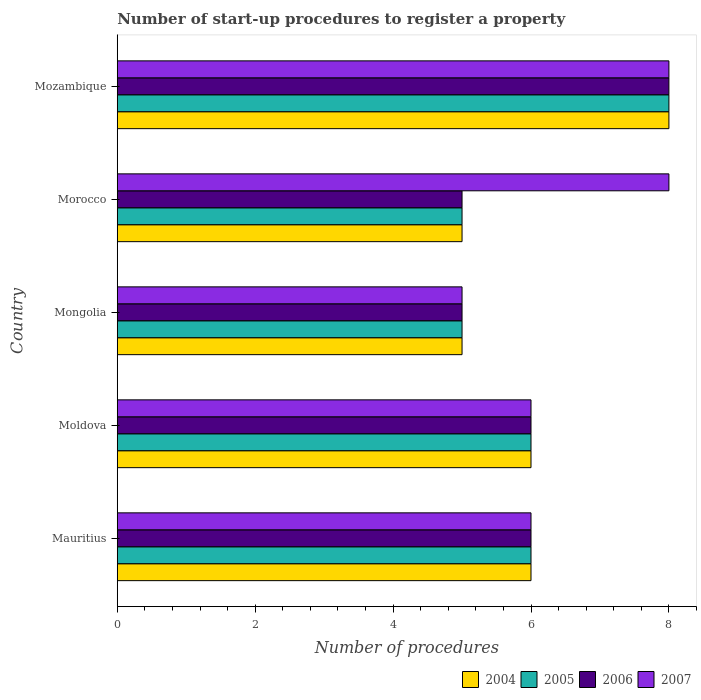How many groups of bars are there?
Make the answer very short. 5. Are the number of bars per tick equal to the number of legend labels?
Your response must be concise. Yes. How many bars are there on the 1st tick from the top?
Make the answer very short. 4. How many bars are there on the 2nd tick from the bottom?
Give a very brief answer. 4. What is the label of the 2nd group of bars from the top?
Provide a short and direct response. Morocco. Across all countries, what is the minimum number of procedures required to register a property in 2004?
Provide a short and direct response. 5. In which country was the number of procedures required to register a property in 2004 maximum?
Offer a very short reply. Mozambique. In which country was the number of procedures required to register a property in 2005 minimum?
Offer a terse response. Mongolia. What is the difference between the number of procedures required to register a property in 2005 in Moldova and that in Mongolia?
Your answer should be compact. 1. What is the difference between the number of procedures required to register a property in 2007 in Moldova and the number of procedures required to register a property in 2005 in Mauritius?
Offer a very short reply. 0. Is the number of procedures required to register a property in 2004 in Moldova less than that in Mongolia?
Offer a very short reply. No. Is the difference between the number of procedures required to register a property in 2007 in Moldova and Mozambique greater than the difference between the number of procedures required to register a property in 2004 in Moldova and Mozambique?
Your response must be concise. No. What is the difference between the highest and the second highest number of procedures required to register a property in 2007?
Offer a terse response. 0. Is the sum of the number of procedures required to register a property in 2004 in Mongolia and Mozambique greater than the maximum number of procedures required to register a property in 2007 across all countries?
Keep it short and to the point. Yes. What does the 1st bar from the top in Mauritius represents?
Your response must be concise. 2007. Is it the case that in every country, the sum of the number of procedures required to register a property in 2007 and number of procedures required to register a property in 2005 is greater than the number of procedures required to register a property in 2004?
Offer a terse response. Yes. How many bars are there?
Keep it short and to the point. 20. Are all the bars in the graph horizontal?
Give a very brief answer. Yes. What is the difference between two consecutive major ticks on the X-axis?
Provide a short and direct response. 2. How many legend labels are there?
Your response must be concise. 4. How are the legend labels stacked?
Your answer should be compact. Horizontal. What is the title of the graph?
Your answer should be very brief. Number of start-up procedures to register a property. Does "1968" appear as one of the legend labels in the graph?
Your response must be concise. No. What is the label or title of the X-axis?
Make the answer very short. Number of procedures. What is the label or title of the Y-axis?
Offer a very short reply. Country. What is the Number of procedures in 2004 in Mauritius?
Ensure brevity in your answer.  6. What is the Number of procedures of 2005 in Moldova?
Give a very brief answer. 6. What is the Number of procedures in 2006 in Moldova?
Provide a short and direct response. 6. What is the Number of procedures in 2007 in Moldova?
Your answer should be compact. 6. What is the Number of procedures in 2004 in Mongolia?
Ensure brevity in your answer.  5. What is the Number of procedures in 2005 in Mongolia?
Make the answer very short. 5. What is the Number of procedures of 2004 in Morocco?
Your response must be concise. 5. What is the Number of procedures of 2006 in Morocco?
Provide a short and direct response. 5. What is the Number of procedures in 2005 in Mozambique?
Give a very brief answer. 8. What is the Number of procedures in 2006 in Mozambique?
Your response must be concise. 8. What is the Number of procedures in 2007 in Mozambique?
Make the answer very short. 8. Across all countries, what is the maximum Number of procedures of 2004?
Ensure brevity in your answer.  8. Across all countries, what is the maximum Number of procedures of 2005?
Offer a terse response. 8. Across all countries, what is the minimum Number of procedures in 2005?
Your answer should be very brief. 5. What is the total Number of procedures in 2004 in the graph?
Your response must be concise. 30. What is the total Number of procedures of 2005 in the graph?
Provide a succinct answer. 30. What is the difference between the Number of procedures of 2004 in Mauritius and that in Moldova?
Make the answer very short. 0. What is the difference between the Number of procedures of 2005 in Mauritius and that in Moldova?
Keep it short and to the point. 0. What is the difference between the Number of procedures in 2006 in Mauritius and that in Moldova?
Keep it short and to the point. 0. What is the difference between the Number of procedures in 2005 in Mauritius and that in Mongolia?
Your answer should be compact. 1. What is the difference between the Number of procedures in 2007 in Mauritius and that in Mongolia?
Provide a succinct answer. 1. What is the difference between the Number of procedures in 2004 in Mauritius and that in Morocco?
Your answer should be compact. 1. What is the difference between the Number of procedures in 2006 in Mauritius and that in Morocco?
Give a very brief answer. 1. What is the difference between the Number of procedures in 2007 in Mauritius and that in Morocco?
Make the answer very short. -2. What is the difference between the Number of procedures in 2004 in Mauritius and that in Mozambique?
Offer a very short reply. -2. What is the difference between the Number of procedures in 2005 in Mauritius and that in Mozambique?
Provide a succinct answer. -2. What is the difference between the Number of procedures in 2006 in Mauritius and that in Mozambique?
Ensure brevity in your answer.  -2. What is the difference between the Number of procedures of 2007 in Mauritius and that in Mozambique?
Make the answer very short. -2. What is the difference between the Number of procedures in 2004 in Moldova and that in Mongolia?
Provide a short and direct response. 1. What is the difference between the Number of procedures of 2005 in Moldova and that in Mongolia?
Give a very brief answer. 1. What is the difference between the Number of procedures of 2007 in Moldova and that in Mongolia?
Offer a terse response. 1. What is the difference between the Number of procedures in 2004 in Moldova and that in Morocco?
Make the answer very short. 1. What is the difference between the Number of procedures of 2005 in Moldova and that in Morocco?
Offer a very short reply. 1. What is the difference between the Number of procedures in 2005 in Mongolia and that in Mozambique?
Give a very brief answer. -3. What is the difference between the Number of procedures in 2007 in Mongolia and that in Mozambique?
Offer a terse response. -3. What is the difference between the Number of procedures in 2004 in Morocco and that in Mozambique?
Offer a terse response. -3. What is the difference between the Number of procedures in 2005 in Morocco and that in Mozambique?
Your answer should be very brief. -3. What is the difference between the Number of procedures in 2007 in Morocco and that in Mozambique?
Your answer should be very brief. 0. What is the difference between the Number of procedures in 2004 in Mauritius and the Number of procedures in 2005 in Moldova?
Make the answer very short. 0. What is the difference between the Number of procedures in 2004 in Mauritius and the Number of procedures in 2007 in Moldova?
Provide a short and direct response. 0. What is the difference between the Number of procedures in 2005 in Mauritius and the Number of procedures in 2006 in Moldova?
Provide a short and direct response. 0. What is the difference between the Number of procedures of 2004 in Mauritius and the Number of procedures of 2006 in Mongolia?
Offer a very short reply. 1. What is the difference between the Number of procedures of 2005 in Mauritius and the Number of procedures of 2006 in Mongolia?
Ensure brevity in your answer.  1. What is the difference between the Number of procedures in 2005 in Mauritius and the Number of procedures in 2007 in Mongolia?
Your response must be concise. 1. What is the difference between the Number of procedures in 2004 in Mauritius and the Number of procedures in 2005 in Morocco?
Offer a very short reply. 1. What is the difference between the Number of procedures in 2004 in Mauritius and the Number of procedures in 2006 in Morocco?
Provide a short and direct response. 1. What is the difference between the Number of procedures of 2004 in Mauritius and the Number of procedures of 2007 in Morocco?
Your response must be concise. -2. What is the difference between the Number of procedures in 2005 in Mauritius and the Number of procedures in 2006 in Morocco?
Provide a succinct answer. 1. What is the difference between the Number of procedures in 2005 in Mauritius and the Number of procedures in 2007 in Morocco?
Your answer should be very brief. -2. What is the difference between the Number of procedures in 2004 in Mauritius and the Number of procedures in 2005 in Mozambique?
Give a very brief answer. -2. What is the difference between the Number of procedures in 2004 in Mauritius and the Number of procedures in 2006 in Mozambique?
Provide a short and direct response. -2. What is the difference between the Number of procedures of 2004 in Mauritius and the Number of procedures of 2007 in Mozambique?
Provide a succinct answer. -2. What is the difference between the Number of procedures in 2006 in Mauritius and the Number of procedures in 2007 in Mozambique?
Keep it short and to the point. -2. What is the difference between the Number of procedures in 2004 in Moldova and the Number of procedures in 2006 in Mongolia?
Keep it short and to the point. 1. What is the difference between the Number of procedures of 2004 in Moldova and the Number of procedures of 2007 in Mongolia?
Provide a short and direct response. 1. What is the difference between the Number of procedures in 2006 in Moldova and the Number of procedures in 2007 in Mongolia?
Make the answer very short. 1. What is the difference between the Number of procedures of 2004 in Moldova and the Number of procedures of 2005 in Morocco?
Ensure brevity in your answer.  1. What is the difference between the Number of procedures in 2004 in Moldova and the Number of procedures in 2006 in Morocco?
Ensure brevity in your answer.  1. What is the difference between the Number of procedures in 2004 in Moldova and the Number of procedures in 2007 in Morocco?
Give a very brief answer. -2. What is the difference between the Number of procedures in 2006 in Moldova and the Number of procedures in 2007 in Morocco?
Your answer should be compact. -2. What is the difference between the Number of procedures of 2004 in Moldova and the Number of procedures of 2005 in Mozambique?
Your answer should be very brief. -2. What is the difference between the Number of procedures of 2004 in Moldova and the Number of procedures of 2006 in Mozambique?
Offer a terse response. -2. What is the difference between the Number of procedures in 2005 in Moldova and the Number of procedures in 2007 in Mozambique?
Your answer should be compact. -2. What is the difference between the Number of procedures of 2004 in Mongolia and the Number of procedures of 2006 in Morocco?
Provide a succinct answer. 0. What is the difference between the Number of procedures of 2004 in Mongolia and the Number of procedures of 2007 in Morocco?
Provide a succinct answer. -3. What is the difference between the Number of procedures of 2005 in Mongolia and the Number of procedures of 2006 in Morocco?
Keep it short and to the point. 0. What is the difference between the Number of procedures of 2006 in Mongolia and the Number of procedures of 2007 in Morocco?
Your answer should be compact. -3. What is the difference between the Number of procedures of 2004 in Mongolia and the Number of procedures of 2005 in Mozambique?
Provide a short and direct response. -3. What is the difference between the Number of procedures in 2004 in Mongolia and the Number of procedures in 2006 in Mozambique?
Provide a succinct answer. -3. What is the difference between the Number of procedures of 2005 in Mongolia and the Number of procedures of 2006 in Mozambique?
Your answer should be very brief. -3. What is the difference between the Number of procedures in 2005 in Mongolia and the Number of procedures in 2007 in Mozambique?
Give a very brief answer. -3. What is the difference between the Number of procedures of 2004 in Morocco and the Number of procedures of 2006 in Mozambique?
Offer a terse response. -3. What is the difference between the Number of procedures of 2004 in Morocco and the Number of procedures of 2007 in Mozambique?
Provide a succinct answer. -3. What is the difference between the Number of procedures in 2005 in Morocco and the Number of procedures in 2006 in Mozambique?
Provide a short and direct response. -3. What is the difference between the Number of procedures in 2005 in Morocco and the Number of procedures in 2007 in Mozambique?
Your answer should be compact. -3. What is the difference between the Number of procedures of 2006 in Morocco and the Number of procedures of 2007 in Mozambique?
Offer a very short reply. -3. What is the average Number of procedures in 2004 per country?
Give a very brief answer. 6. What is the average Number of procedures of 2006 per country?
Offer a very short reply. 6. What is the average Number of procedures of 2007 per country?
Provide a succinct answer. 6.6. What is the difference between the Number of procedures of 2004 and Number of procedures of 2007 in Mauritius?
Provide a short and direct response. 0. What is the difference between the Number of procedures in 2005 and Number of procedures in 2006 in Mauritius?
Make the answer very short. 0. What is the difference between the Number of procedures in 2006 and Number of procedures in 2007 in Mauritius?
Your answer should be very brief. 0. What is the difference between the Number of procedures of 2004 and Number of procedures of 2005 in Moldova?
Give a very brief answer. 0. What is the difference between the Number of procedures in 2004 and Number of procedures in 2006 in Moldova?
Provide a short and direct response. 0. What is the difference between the Number of procedures in 2004 and Number of procedures in 2007 in Moldova?
Your answer should be very brief. 0. What is the difference between the Number of procedures of 2005 and Number of procedures of 2006 in Moldova?
Keep it short and to the point. 0. What is the difference between the Number of procedures in 2005 and Number of procedures in 2007 in Moldova?
Your answer should be very brief. 0. What is the difference between the Number of procedures in 2004 and Number of procedures in 2005 in Mongolia?
Provide a succinct answer. 0. What is the difference between the Number of procedures of 2004 and Number of procedures of 2006 in Mongolia?
Give a very brief answer. 0. What is the difference between the Number of procedures of 2006 and Number of procedures of 2007 in Mongolia?
Make the answer very short. 0. What is the difference between the Number of procedures of 2004 and Number of procedures of 2005 in Morocco?
Make the answer very short. 0. What is the difference between the Number of procedures of 2004 and Number of procedures of 2006 in Morocco?
Offer a terse response. 0. What is the difference between the Number of procedures of 2004 and Number of procedures of 2007 in Morocco?
Your answer should be compact. -3. What is the difference between the Number of procedures in 2005 and Number of procedures in 2006 in Morocco?
Offer a terse response. 0. What is the difference between the Number of procedures of 2006 and Number of procedures of 2007 in Morocco?
Keep it short and to the point. -3. What is the difference between the Number of procedures in 2004 and Number of procedures in 2007 in Mozambique?
Offer a terse response. 0. What is the difference between the Number of procedures of 2006 and Number of procedures of 2007 in Mozambique?
Provide a short and direct response. 0. What is the ratio of the Number of procedures in 2004 in Mauritius to that in Moldova?
Offer a terse response. 1. What is the ratio of the Number of procedures of 2005 in Mauritius to that in Mongolia?
Offer a very short reply. 1.2. What is the ratio of the Number of procedures in 2006 in Mauritius to that in Mongolia?
Offer a terse response. 1.2. What is the ratio of the Number of procedures of 2007 in Mauritius to that in Mongolia?
Offer a terse response. 1.2. What is the ratio of the Number of procedures of 2005 in Moldova to that in Mongolia?
Provide a succinct answer. 1.2. What is the ratio of the Number of procedures of 2006 in Moldova to that in Mongolia?
Provide a succinct answer. 1.2. What is the ratio of the Number of procedures of 2004 in Moldova to that in Morocco?
Keep it short and to the point. 1.2. What is the ratio of the Number of procedures of 2004 in Moldova to that in Mozambique?
Keep it short and to the point. 0.75. What is the ratio of the Number of procedures of 2005 in Moldova to that in Mozambique?
Ensure brevity in your answer.  0.75. What is the ratio of the Number of procedures in 2005 in Mongolia to that in Morocco?
Keep it short and to the point. 1. What is the ratio of the Number of procedures in 2007 in Mongolia to that in Morocco?
Offer a very short reply. 0.62. What is the ratio of the Number of procedures in 2004 in Morocco to that in Mozambique?
Offer a terse response. 0.62. What is the ratio of the Number of procedures in 2005 in Morocco to that in Mozambique?
Make the answer very short. 0.62. What is the ratio of the Number of procedures of 2007 in Morocco to that in Mozambique?
Offer a very short reply. 1. What is the difference between the highest and the second highest Number of procedures in 2005?
Provide a short and direct response. 2. What is the difference between the highest and the second highest Number of procedures of 2006?
Offer a terse response. 2. What is the difference between the highest and the lowest Number of procedures of 2005?
Keep it short and to the point. 3. 